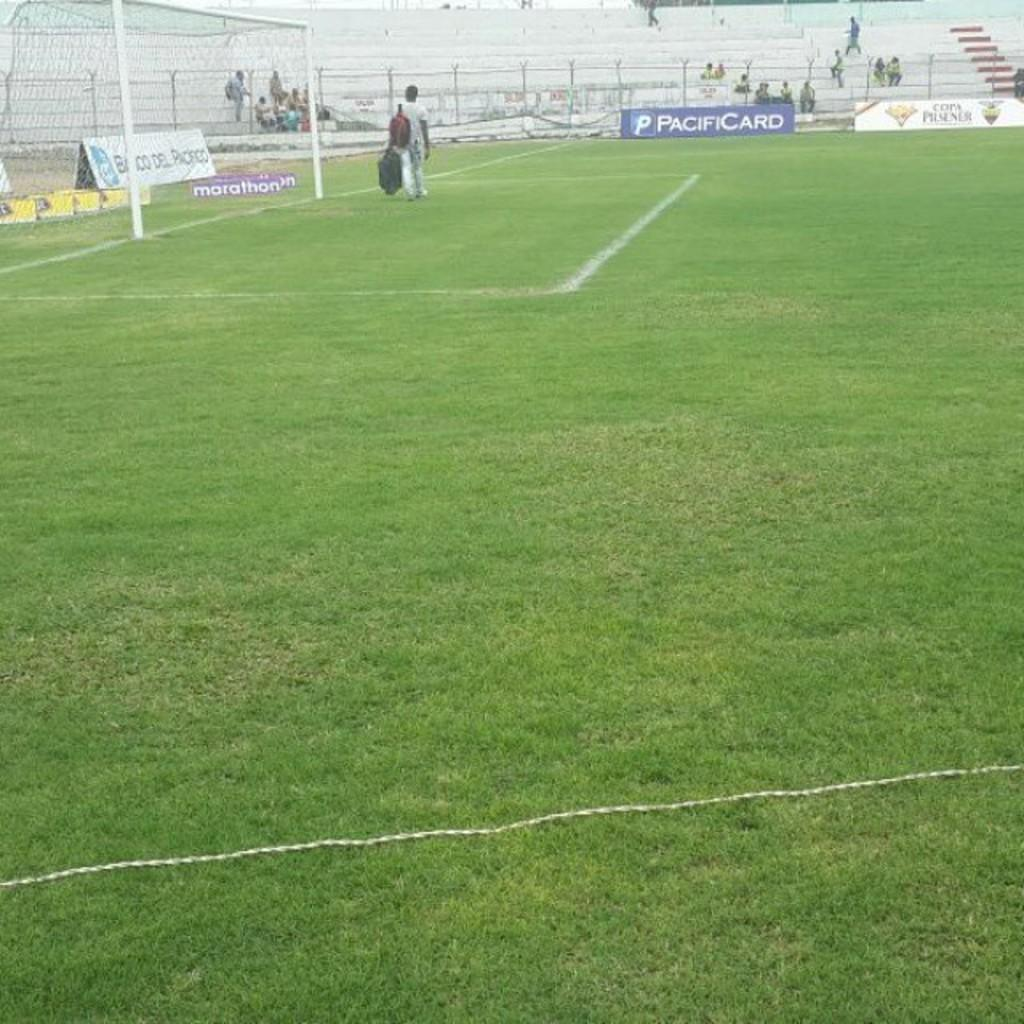<image>
Render a clear and concise summary of the photo. A large sports field with advertisement signs and a banner that says PacifiCard across the bleacher area. 